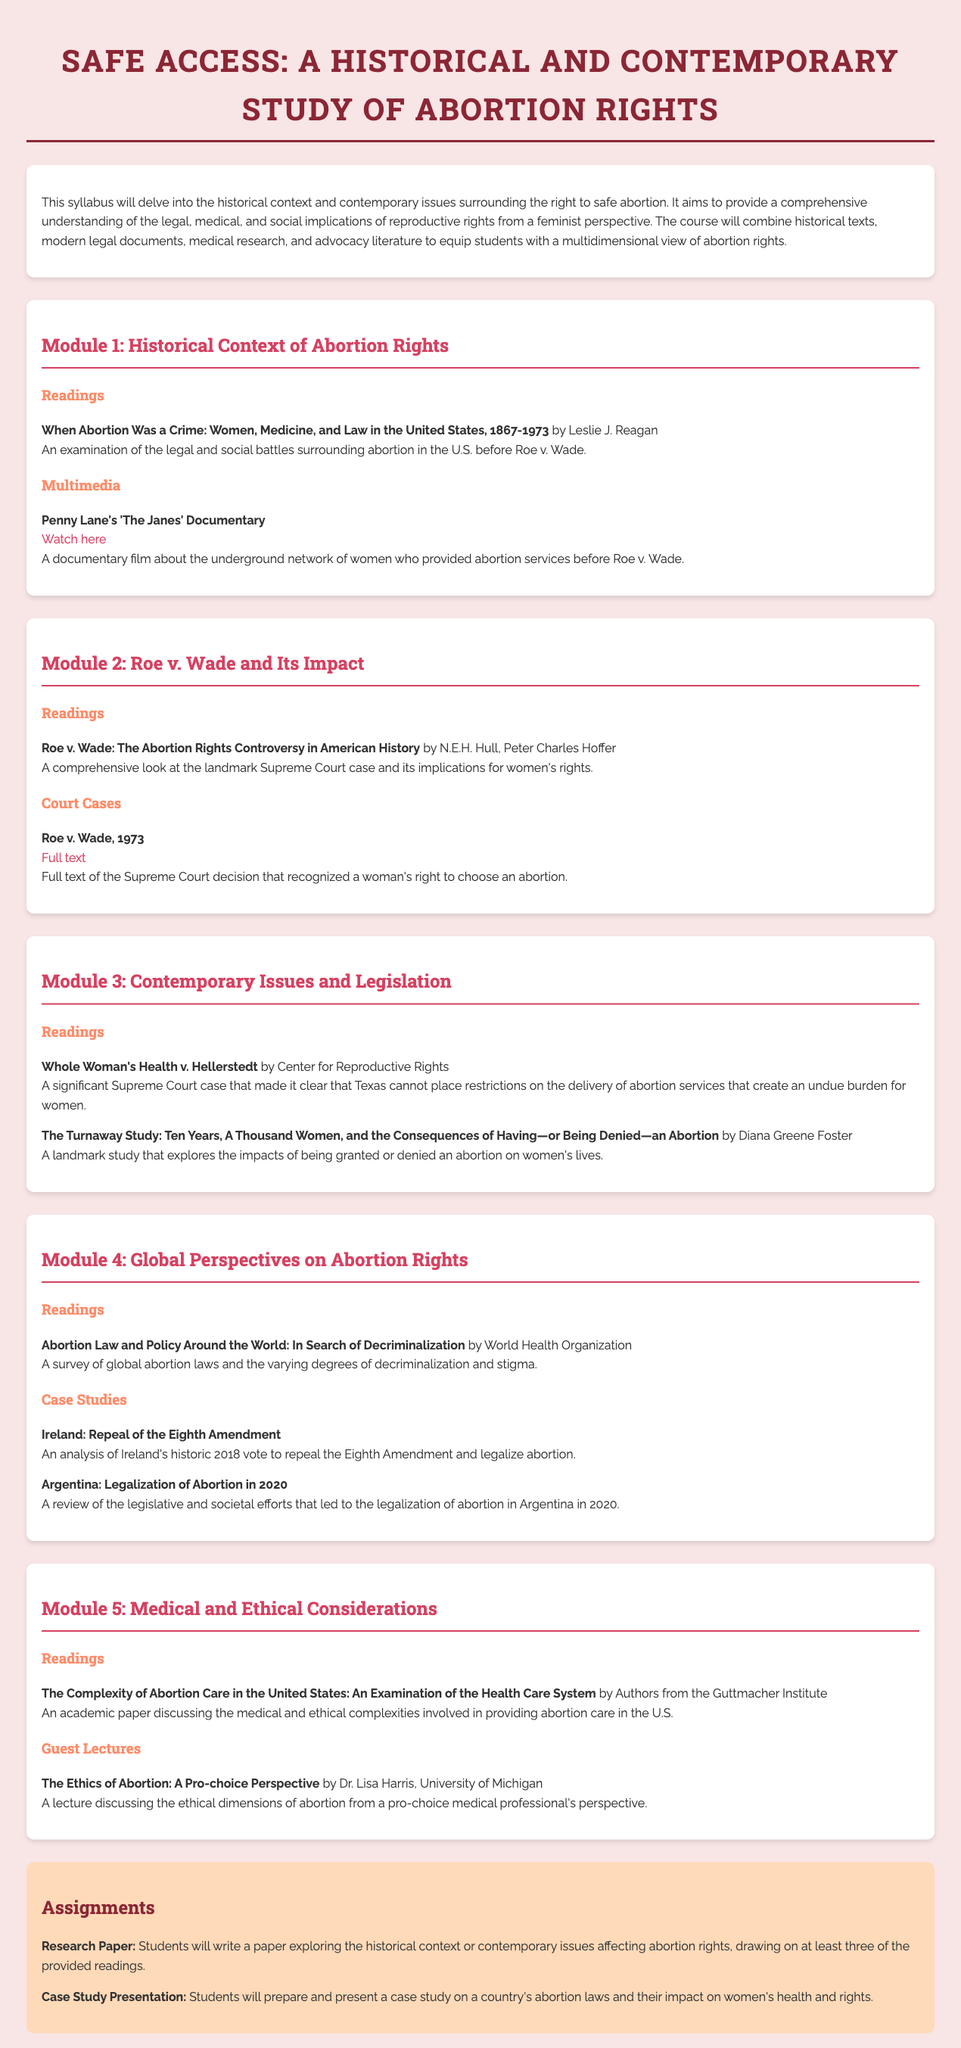What is the title of the syllabus? The title of the syllabus is the main heading at the top of the document, which outlines the focus area of the course.
Answer: Safe Access: A Historical and Contemporary Study of Abortion Rights Who is the author of "When Abortion Was a Crime"? The author is mentioned in the reading list of Module 1, providing historical insights into abortion laws.
Answer: Leslie J. Reagan What year was Roe v. Wade decided? The document specifies the significant case's year in relation to women's rights and legal context discussed in Module 2.
Answer: 1973 What landmark study is mentioned in Module 3? This study is highlighted to understand the effects of abortion access in the contemporary context and is crucial for Module 3's topic.
Answer: The Turnaway Study Which country repealed the Eighth Amendment? The document identifies Ireland's historic legislative change as part of its analysis in Module 4 concerning global perspectives.
Answer: Ireland What type of presentation is required in assignments? The assignments section outlines what students are expected to prepare and present, which relates to the course focus.
Answer: Case Study Presentation Who is the guest lecturer for the ethics of abortion? This detail is provided in Module 5 to highlight the expert contributions to the course discourse, focusing on ethical dimensions.
Answer: Dr. Lisa Harris How many modules are included in the syllabus? The total number of modules is specified to organize the course content and structure effectively.
Answer: Five 